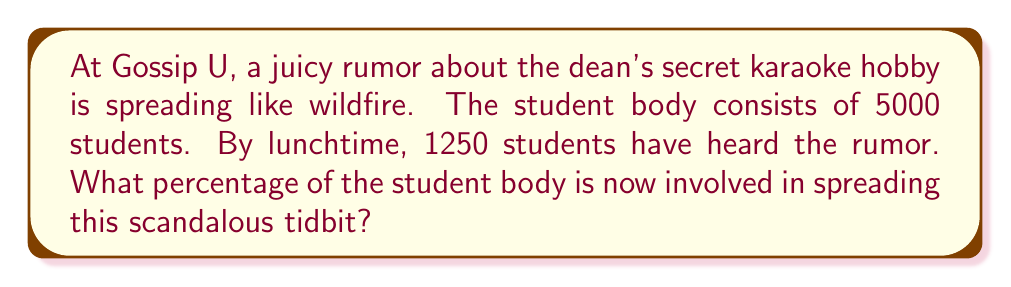Teach me how to tackle this problem. To calculate the percentage of students involved in the rumor, we need to follow these steps:

1. Identify the total number of students (total population):
   Total students = 5000

2. Identify the number of students who have heard the rumor:
   Students involved = 1250

3. Use the formula for calculating percentage:
   $$ \text{Percentage} = \frac{\text{Part}}{\text{Whole}} \times 100\% $$

4. Plug in the values:
   $$ \text{Percentage} = \frac{1250}{5000} \times 100\% $$

5. Simplify the fraction:
   $$ \text{Percentage} = \frac{1}{4} \times 100\% $$

6. Multiply:
   $$ \text{Percentage} = 0.25 \times 100\% = 25\% $$

Therefore, 25% of the student body is involved in spreading the rumor about the dean's secret karaoke hobby.
Answer: 25% 